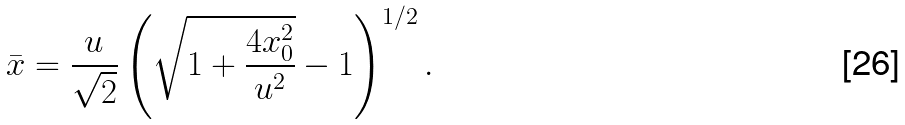Convert formula to latex. <formula><loc_0><loc_0><loc_500><loc_500>\bar { x } = \frac { u } { \sqrt { 2 } } \left ( \sqrt { 1 + \frac { 4 x _ { 0 } ^ { 2 } } { u ^ { 2 } } } - 1 \right ) ^ { 1 / 2 } .</formula> 